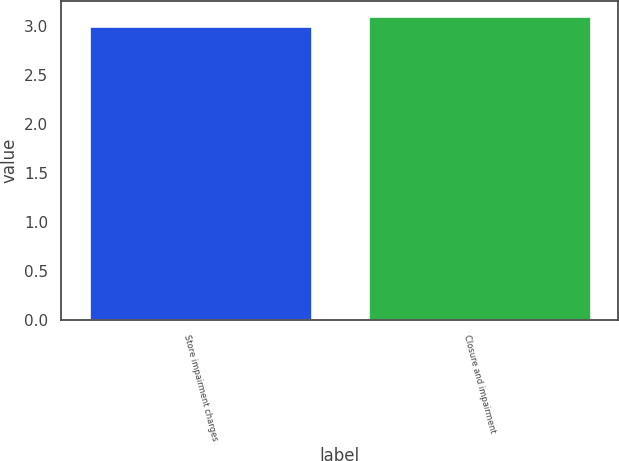Convert chart to OTSL. <chart><loc_0><loc_0><loc_500><loc_500><bar_chart><fcel>Store impairment charges<fcel>Closure and impairment<nl><fcel>3<fcel>3.1<nl></chart> 